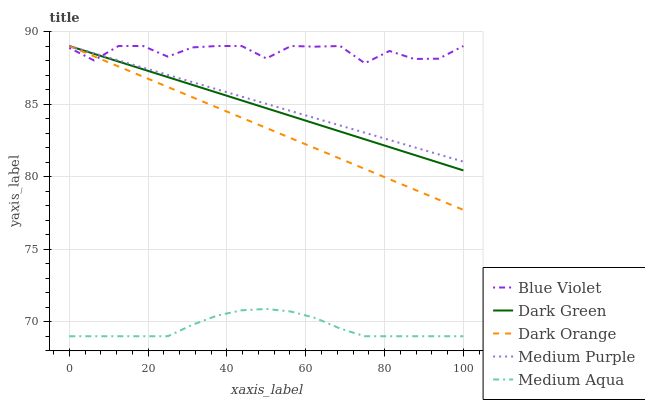Does Medium Aqua have the minimum area under the curve?
Answer yes or no. Yes. Does Blue Violet have the maximum area under the curve?
Answer yes or no. Yes. Does Dark Orange have the minimum area under the curve?
Answer yes or no. No. Does Dark Orange have the maximum area under the curve?
Answer yes or no. No. Is Dark Green the smoothest?
Answer yes or no. Yes. Is Blue Violet the roughest?
Answer yes or no. Yes. Is Dark Orange the smoothest?
Answer yes or no. No. Is Dark Orange the roughest?
Answer yes or no. No. Does Dark Orange have the lowest value?
Answer yes or no. No. Does Medium Aqua have the highest value?
Answer yes or no. No. Is Medium Aqua less than Dark Green?
Answer yes or no. Yes. Is Medium Purple greater than Medium Aqua?
Answer yes or no. Yes. Does Medium Aqua intersect Dark Green?
Answer yes or no. No. 